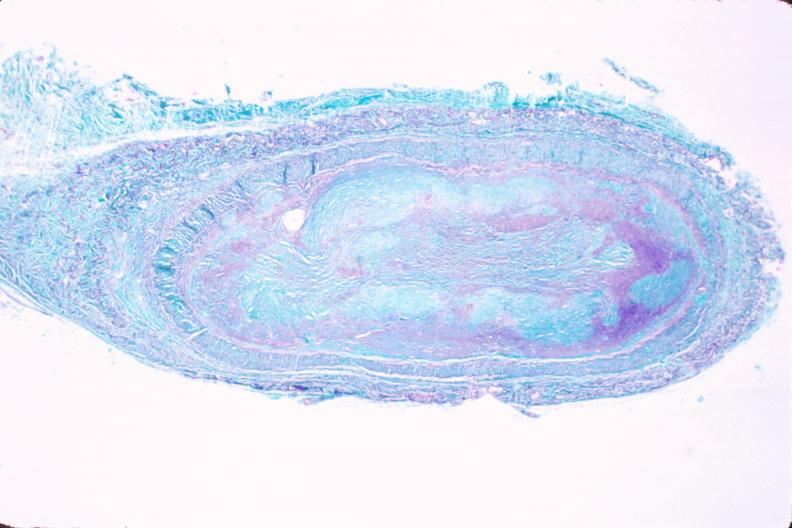s cardiovascular present?
Answer the question using a single word or phrase. Yes 